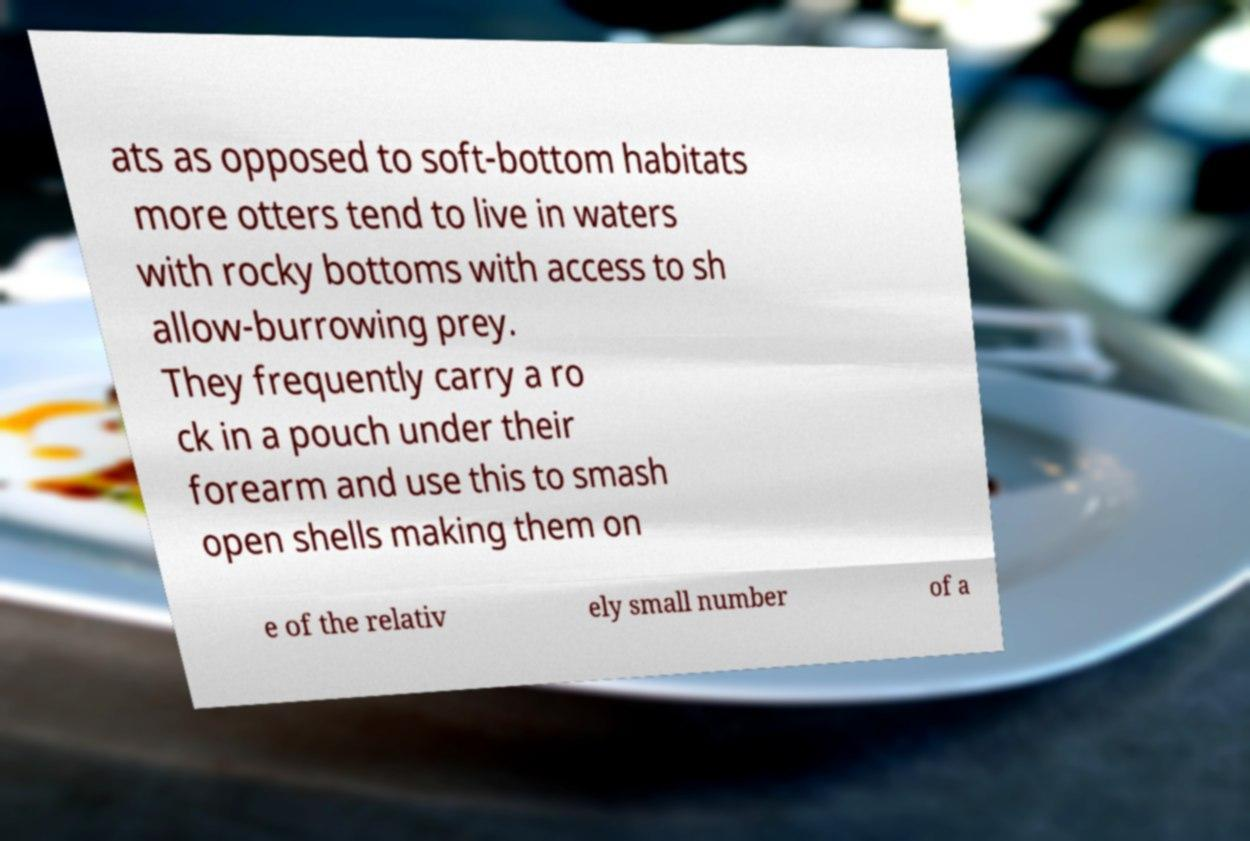Can you read and provide the text displayed in the image?This photo seems to have some interesting text. Can you extract and type it out for me? ats as opposed to soft-bottom habitats more otters tend to live in waters with rocky bottoms with access to sh allow-burrowing prey. They frequently carry a ro ck in a pouch under their forearm and use this to smash open shells making them on e of the relativ ely small number of a 